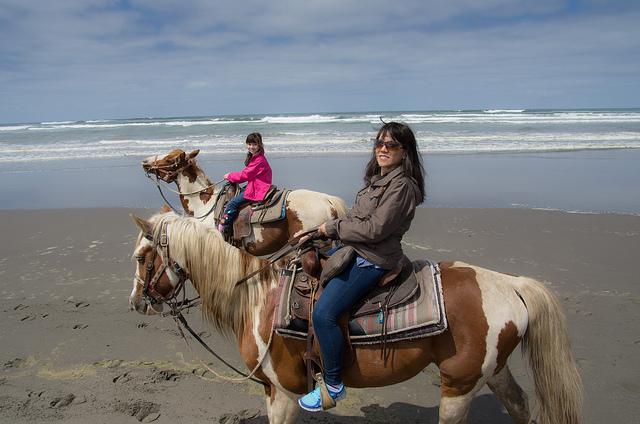Are the riders wearing gloves?
Write a very short answer. No. What color is the little girls coat?
Write a very short answer. Pink. Do they look like they are having fun?
Keep it brief. Yes. 